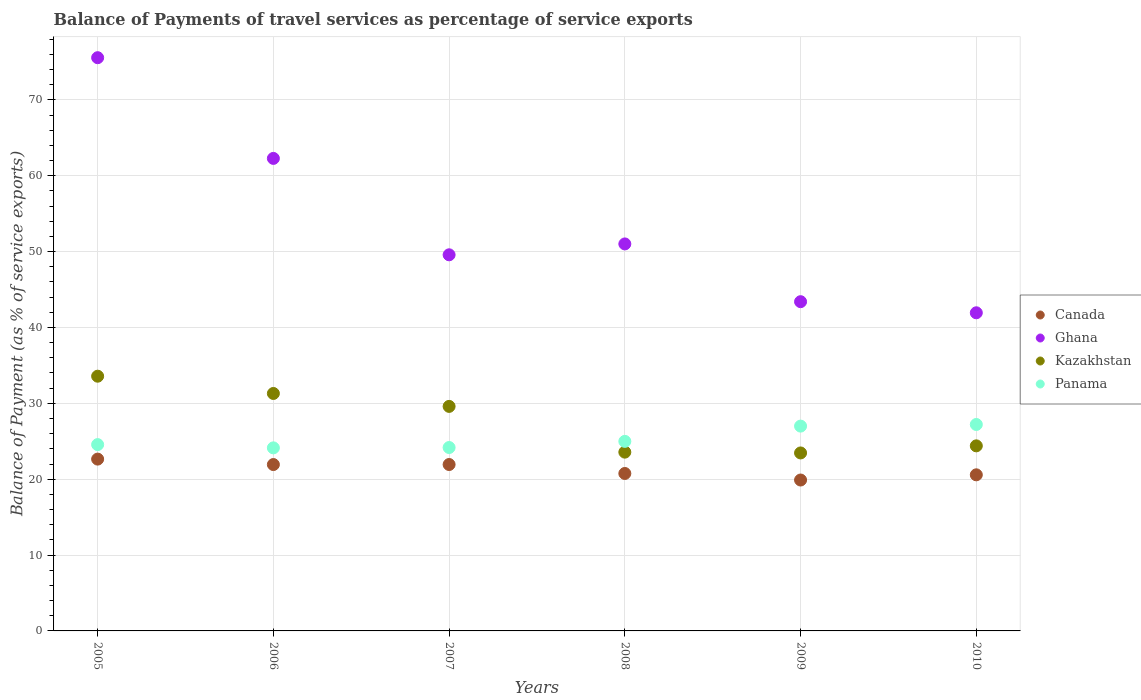How many different coloured dotlines are there?
Give a very brief answer. 4. Is the number of dotlines equal to the number of legend labels?
Provide a short and direct response. Yes. What is the balance of payments of travel services in Panama in 2007?
Your answer should be very brief. 24.18. Across all years, what is the maximum balance of payments of travel services in Kazakhstan?
Keep it short and to the point. 33.58. Across all years, what is the minimum balance of payments of travel services in Panama?
Your answer should be compact. 24.13. What is the total balance of payments of travel services in Ghana in the graph?
Provide a short and direct response. 323.78. What is the difference between the balance of payments of travel services in Panama in 2005 and that in 2010?
Your response must be concise. -2.65. What is the difference between the balance of payments of travel services in Kazakhstan in 2006 and the balance of payments of travel services in Canada in 2010?
Your answer should be compact. 10.72. What is the average balance of payments of travel services in Panama per year?
Offer a very short reply. 25.34. In the year 2010, what is the difference between the balance of payments of travel services in Canada and balance of payments of travel services in Ghana?
Offer a terse response. -21.36. In how many years, is the balance of payments of travel services in Kazakhstan greater than 64 %?
Ensure brevity in your answer.  0. What is the ratio of the balance of payments of travel services in Panama in 2005 to that in 2010?
Ensure brevity in your answer.  0.9. Is the balance of payments of travel services in Panama in 2009 less than that in 2010?
Make the answer very short. Yes. Is the difference between the balance of payments of travel services in Canada in 2007 and 2008 greater than the difference between the balance of payments of travel services in Ghana in 2007 and 2008?
Offer a terse response. Yes. What is the difference between the highest and the second highest balance of payments of travel services in Canada?
Keep it short and to the point. 0.71. What is the difference between the highest and the lowest balance of payments of travel services in Ghana?
Your answer should be very brief. 33.63. Is it the case that in every year, the sum of the balance of payments of travel services in Canada and balance of payments of travel services in Ghana  is greater than the sum of balance of payments of travel services in Panama and balance of payments of travel services in Kazakhstan?
Offer a very short reply. No. Is it the case that in every year, the sum of the balance of payments of travel services in Ghana and balance of payments of travel services in Canada  is greater than the balance of payments of travel services in Panama?
Provide a succinct answer. Yes. Does the balance of payments of travel services in Panama monotonically increase over the years?
Provide a succinct answer. No. Is the balance of payments of travel services in Canada strictly less than the balance of payments of travel services in Kazakhstan over the years?
Provide a succinct answer. Yes. How many dotlines are there?
Your response must be concise. 4. How many years are there in the graph?
Your answer should be compact. 6. Are the values on the major ticks of Y-axis written in scientific E-notation?
Your answer should be compact. No. Does the graph contain any zero values?
Your response must be concise. No. Does the graph contain grids?
Offer a very short reply. Yes. Where does the legend appear in the graph?
Offer a terse response. Center right. How many legend labels are there?
Make the answer very short. 4. What is the title of the graph?
Your response must be concise. Balance of Payments of travel services as percentage of service exports. What is the label or title of the X-axis?
Your response must be concise. Years. What is the label or title of the Y-axis?
Offer a very short reply. Balance of Payment (as % of service exports). What is the Balance of Payment (as % of service exports) of Canada in 2005?
Your response must be concise. 22.65. What is the Balance of Payment (as % of service exports) of Ghana in 2005?
Your answer should be compact. 75.56. What is the Balance of Payment (as % of service exports) in Kazakhstan in 2005?
Make the answer very short. 33.58. What is the Balance of Payment (as % of service exports) in Panama in 2005?
Give a very brief answer. 24.56. What is the Balance of Payment (as % of service exports) of Canada in 2006?
Your response must be concise. 21.93. What is the Balance of Payment (as % of service exports) of Ghana in 2006?
Make the answer very short. 62.29. What is the Balance of Payment (as % of service exports) in Kazakhstan in 2006?
Your answer should be compact. 31.3. What is the Balance of Payment (as % of service exports) of Panama in 2006?
Your response must be concise. 24.13. What is the Balance of Payment (as % of service exports) in Canada in 2007?
Your response must be concise. 21.94. What is the Balance of Payment (as % of service exports) of Ghana in 2007?
Provide a succinct answer. 49.58. What is the Balance of Payment (as % of service exports) of Kazakhstan in 2007?
Ensure brevity in your answer.  29.6. What is the Balance of Payment (as % of service exports) in Panama in 2007?
Your response must be concise. 24.18. What is the Balance of Payment (as % of service exports) in Canada in 2008?
Your answer should be compact. 20.75. What is the Balance of Payment (as % of service exports) in Ghana in 2008?
Your answer should be very brief. 51.01. What is the Balance of Payment (as % of service exports) in Kazakhstan in 2008?
Keep it short and to the point. 23.57. What is the Balance of Payment (as % of service exports) in Panama in 2008?
Offer a terse response. 24.99. What is the Balance of Payment (as % of service exports) in Canada in 2009?
Provide a succinct answer. 19.89. What is the Balance of Payment (as % of service exports) of Ghana in 2009?
Provide a short and direct response. 43.4. What is the Balance of Payment (as % of service exports) in Kazakhstan in 2009?
Offer a very short reply. 23.46. What is the Balance of Payment (as % of service exports) of Panama in 2009?
Offer a terse response. 27. What is the Balance of Payment (as % of service exports) of Canada in 2010?
Your answer should be very brief. 20.58. What is the Balance of Payment (as % of service exports) in Ghana in 2010?
Make the answer very short. 41.94. What is the Balance of Payment (as % of service exports) in Kazakhstan in 2010?
Give a very brief answer. 24.39. What is the Balance of Payment (as % of service exports) of Panama in 2010?
Your answer should be compact. 27.21. Across all years, what is the maximum Balance of Payment (as % of service exports) in Canada?
Provide a succinct answer. 22.65. Across all years, what is the maximum Balance of Payment (as % of service exports) in Ghana?
Make the answer very short. 75.56. Across all years, what is the maximum Balance of Payment (as % of service exports) in Kazakhstan?
Give a very brief answer. 33.58. Across all years, what is the maximum Balance of Payment (as % of service exports) of Panama?
Your response must be concise. 27.21. Across all years, what is the minimum Balance of Payment (as % of service exports) of Canada?
Offer a terse response. 19.89. Across all years, what is the minimum Balance of Payment (as % of service exports) in Ghana?
Provide a short and direct response. 41.94. Across all years, what is the minimum Balance of Payment (as % of service exports) in Kazakhstan?
Your response must be concise. 23.46. Across all years, what is the minimum Balance of Payment (as % of service exports) in Panama?
Offer a terse response. 24.13. What is the total Balance of Payment (as % of service exports) in Canada in the graph?
Offer a terse response. 127.74. What is the total Balance of Payment (as % of service exports) of Ghana in the graph?
Give a very brief answer. 323.78. What is the total Balance of Payment (as % of service exports) in Kazakhstan in the graph?
Your answer should be compact. 165.9. What is the total Balance of Payment (as % of service exports) in Panama in the graph?
Offer a terse response. 152.06. What is the difference between the Balance of Payment (as % of service exports) of Canada in 2005 and that in 2006?
Ensure brevity in your answer.  0.72. What is the difference between the Balance of Payment (as % of service exports) of Ghana in 2005 and that in 2006?
Your answer should be compact. 13.28. What is the difference between the Balance of Payment (as % of service exports) of Kazakhstan in 2005 and that in 2006?
Give a very brief answer. 2.28. What is the difference between the Balance of Payment (as % of service exports) in Panama in 2005 and that in 2006?
Your response must be concise. 0.43. What is the difference between the Balance of Payment (as % of service exports) in Canada in 2005 and that in 2007?
Offer a terse response. 0.71. What is the difference between the Balance of Payment (as % of service exports) of Ghana in 2005 and that in 2007?
Your answer should be compact. 25.98. What is the difference between the Balance of Payment (as % of service exports) of Kazakhstan in 2005 and that in 2007?
Your response must be concise. 3.98. What is the difference between the Balance of Payment (as % of service exports) in Panama in 2005 and that in 2007?
Make the answer very short. 0.38. What is the difference between the Balance of Payment (as % of service exports) in Canada in 2005 and that in 2008?
Provide a short and direct response. 1.9. What is the difference between the Balance of Payment (as % of service exports) of Ghana in 2005 and that in 2008?
Provide a short and direct response. 24.55. What is the difference between the Balance of Payment (as % of service exports) of Kazakhstan in 2005 and that in 2008?
Give a very brief answer. 10.01. What is the difference between the Balance of Payment (as % of service exports) of Panama in 2005 and that in 2008?
Make the answer very short. -0.43. What is the difference between the Balance of Payment (as % of service exports) in Canada in 2005 and that in 2009?
Provide a short and direct response. 2.76. What is the difference between the Balance of Payment (as % of service exports) of Ghana in 2005 and that in 2009?
Offer a terse response. 32.16. What is the difference between the Balance of Payment (as % of service exports) of Kazakhstan in 2005 and that in 2009?
Provide a short and direct response. 10.12. What is the difference between the Balance of Payment (as % of service exports) of Panama in 2005 and that in 2009?
Your answer should be compact. -2.44. What is the difference between the Balance of Payment (as % of service exports) in Canada in 2005 and that in 2010?
Offer a very short reply. 2.07. What is the difference between the Balance of Payment (as % of service exports) in Ghana in 2005 and that in 2010?
Your answer should be very brief. 33.63. What is the difference between the Balance of Payment (as % of service exports) in Kazakhstan in 2005 and that in 2010?
Offer a terse response. 9.18. What is the difference between the Balance of Payment (as % of service exports) in Panama in 2005 and that in 2010?
Your answer should be compact. -2.65. What is the difference between the Balance of Payment (as % of service exports) of Canada in 2006 and that in 2007?
Your answer should be very brief. -0.01. What is the difference between the Balance of Payment (as % of service exports) in Ghana in 2006 and that in 2007?
Keep it short and to the point. 12.71. What is the difference between the Balance of Payment (as % of service exports) of Kazakhstan in 2006 and that in 2007?
Ensure brevity in your answer.  1.7. What is the difference between the Balance of Payment (as % of service exports) in Panama in 2006 and that in 2007?
Keep it short and to the point. -0.04. What is the difference between the Balance of Payment (as % of service exports) of Canada in 2006 and that in 2008?
Provide a succinct answer. 1.18. What is the difference between the Balance of Payment (as % of service exports) of Ghana in 2006 and that in 2008?
Provide a succinct answer. 11.27. What is the difference between the Balance of Payment (as % of service exports) of Kazakhstan in 2006 and that in 2008?
Keep it short and to the point. 7.73. What is the difference between the Balance of Payment (as % of service exports) in Panama in 2006 and that in 2008?
Ensure brevity in your answer.  -0.86. What is the difference between the Balance of Payment (as % of service exports) of Canada in 2006 and that in 2009?
Give a very brief answer. 2.04. What is the difference between the Balance of Payment (as % of service exports) of Ghana in 2006 and that in 2009?
Ensure brevity in your answer.  18.89. What is the difference between the Balance of Payment (as % of service exports) of Kazakhstan in 2006 and that in 2009?
Your response must be concise. 7.84. What is the difference between the Balance of Payment (as % of service exports) of Panama in 2006 and that in 2009?
Your answer should be very brief. -2.87. What is the difference between the Balance of Payment (as % of service exports) in Canada in 2006 and that in 2010?
Your response must be concise. 1.35. What is the difference between the Balance of Payment (as % of service exports) of Ghana in 2006 and that in 2010?
Offer a very short reply. 20.35. What is the difference between the Balance of Payment (as % of service exports) of Kazakhstan in 2006 and that in 2010?
Keep it short and to the point. 6.91. What is the difference between the Balance of Payment (as % of service exports) of Panama in 2006 and that in 2010?
Your answer should be compact. -3.08. What is the difference between the Balance of Payment (as % of service exports) of Canada in 2007 and that in 2008?
Ensure brevity in your answer.  1.18. What is the difference between the Balance of Payment (as % of service exports) of Ghana in 2007 and that in 2008?
Offer a terse response. -1.43. What is the difference between the Balance of Payment (as % of service exports) in Kazakhstan in 2007 and that in 2008?
Give a very brief answer. 6.03. What is the difference between the Balance of Payment (as % of service exports) of Panama in 2007 and that in 2008?
Your answer should be very brief. -0.81. What is the difference between the Balance of Payment (as % of service exports) in Canada in 2007 and that in 2009?
Your answer should be very brief. 2.04. What is the difference between the Balance of Payment (as % of service exports) of Ghana in 2007 and that in 2009?
Ensure brevity in your answer.  6.18. What is the difference between the Balance of Payment (as % of service exports) of Kazakhstan in 2007 and that in 2009?
Provide a short and direct response. 6.14. What is the difference between the Balance of Payment (as % of service exports) in Panama in 2007 and that in 2009?
Provide a succinct answer. -2.82. What is the difference between the Balance of Payment (as % of service exports) of Canada in 2007 and that in 2010?
Your answer should be very brief. 1.36. What is the difference between the Balance of Payment (as % of service exports) of Ghana in 2007 and that in 2010?
Offer a terse response. 7.64. What is the difference between the Balance of Payment (as % of service exports) in Kazakhstan in 2007 and that in 2010?
Offer a very short reply. 5.2. What is the difference between the Balance of Payment (as % of service exports) of Panama in 2007 and that in 2010?
Offer a terse response. -3.04. What is the difference between the Balance of Payment (as % of service exports) in Canada in 2008 and that in 2009?
Your answer should be compact. 0.86. What is the difference between the Balance of Payment (as % of service exports) in Ghana in 2008 and that in 2009?
Keep it short and to the point. 7.61. What is the difference between the Balance of Payment (as % of service exports) in Kazakhstan in 2008 and that in 2009?
Offer a very short reply. 0.11. What is the difference between the Balance of Payment (as % of service exports) of Panama in 2008 and that in 2009?
Provide a succinct answer. -2.01. What is the difference between the Balance of Payment (as % of service exports) of Canada in 2008 and that in 2010?
Offer a very short reply. 0.18. What is the difference between the Balance of Payment (as % of service exports) of Ghana in 2008 and that in 2010?
Offer a terse response. 9.08. What is the difference between the Balance of Payment (as % of service exports) in Kazakhstan in 2008 and that in 2010?
Keep it short and to the point. -0.83. What is the difference between the Balance of Payment (as % of service exports) in Panama in 2008 and that in 2010?
Ensure brevity in your answer.  -2.22. What is the difference between the Balance of Payment (as % of service exports) of Canada in 2009 and that in 2010?
Give a very brief answer. -0.69. What is the difference between the Balance of Payment (as % of service exports) of Ghana in 2009 and that in 2010?
Your answer should be compact. 1.46. What is the difference between the Balance of Payment (as % of service exports) of Kazakhstan in 2009 and that in 2010?
Keep it short and to the point. -0.93. What is the difference between the Balance of Payment (as % of service exports) of Panama in 2009 and that in 2010?
Your answer should be compact. -0.21. What is the difference between the Balance of Payment (as % of service exports) in Canada in 2005 and the Balance of Payment (as % of service exports) in Ghana in 2006?
Your answer should be very brief. -39.64. What is the difference between the Balance of Payment (as % of service exports) of Canada in 2005 and the Balance of Payment (as % of service exports) of Kazakhstan in 2006?
Ensure brevity in your answer.  -8.65. What is the difference between the Balance of Payment (as % of service exports) in Canada in 2005 and the Balance of Payment (as % of service exports) in Panama in 2006?
Provide a short and direct response. -1.48. What is the difference between the Balance of Payment (as % of service exports) of Ghana in 2005 and the Balance of Payment (as % of service exports) of Kazakhstan in 2006?
Keep it short and to the point. 44.26. What is the difference between the Balance of Payment (as % of service exports) in Ghana in 2005 and the Balance of Payment (as % of service exports) in Panama in 2006?
Make the answer very short. 51.43. What is the difference between the Balance of Payment (as % of service exports) in Kazakhstan in 2005 and the Balance of Payment (as % of service exports) in Panama in 2006?
Ensure brevity in your answer.  9.45. What is the difference between the Balance of Payment (as % of service exports) in Canada in 2005 and the Balance of Payment (as % of service exports) in Ghana in 2007?
Ensure brevity in your answer.  -26.93. What is the difference between the Balance of Payment (as % of service exports) of Canada in 2005 and the Balance of Payment (as % of service exports) of Kazakhstan in 2007?
Offer a very short reply. -6.95. What is the difference between the Balance of Payment (as % of service exports) in Canada in 2005 and the Balance of Payment (as % of service exports) in Panama in 2007?
Keep it short and to the point. -1.53. What is the difference between the Balance of Payment (as % of service exports) of Ghana in 2005 and the Balance of Payment (as % of service exports) of Kazakhstan in 2007?
Your response must be concise. 45.97. What is the difference between the Balance of Payment (as % of service exports) in Ghana in 2005 and the Balance of Payment (as % of service exports) in Panama in 2007?
Offer a terse response. 51.39. What is the difference between the Balance of Payment (as % of service exports) of Kazakhstan in 2005 and the Balance of Payment (as % of service exports) of Panama in 2007?
Ensure brevity in your answer.  9.4. What is the difference between the Balance of Payment (as % of service exports) in Canada in 2005 and the Balance of Payment (as % of service exports) in Ghana in 2008?
Provide a short and direct response. -28.36. What is the difference between the Balance of Payment (as % of service exports) in Canada in 2005 and the Balance of Payment (as % of service exports) in Kazakhstan in 2008?
Provide a short and direct response. -0.92. What is the difference between the Balance of Payment (as % of service exports) of Canada in 2005 and the Balance of Payment (as % of service exports) of Panama in 2008?
Give a very brief answer. -2.34. What is the difference between the Balance of Payment (as % of service exports) of Ghana in 2005 and the Balance of Payment (as % of service exports) of Kazakhstan in 2008?
Your answer should be compact. 52. What is the difference between the Balance of Payment (as % of service exports) in Ghana in 2005 and the Balance of Payment (as % of service exports) in Panama in 2008?
Make the answer very short. 50.58. What is the difference between the Balance of Payment (as % of service exports) in Kazakhstan in 2005 and the Balance of Payment (as % of service exports) in Panama in 2008?
Your response must be concise. 8.59. What is the difference between the Balance of Payment (as % of service exports) in Canada in 2005 and the Balance of Payment (as % of service exports) in Ghana in 2009?
Provide a short and direct response. -20.75. What is the difference between the Balance of Payment (as % of service exports) in Canada in 2005 and the Balance of Payment (as % of service exports) in Kazakhstan in 2009?
Your answer should be compact. -0.81. What is the difference between the Balance of Payment (as % of service exports) in Canada in 2005 and the Balance of Payment (as % of service exports) in Panama in 2009?
Give a very brief answer. -4.35. What is the difference between the Balance of Payment (as % of service exports) in Ghana in 2005 and the Balance of Payment (as % of service exports) in Kazakhstan in 2009?
Keep it short and to the point. 52.1. What is the difference between the Balance of Payment (as % of service exports) of Ghana in 2005 and the Balance of Payment (as % of service exports) of Panama in 2009?
Offer a terse response. 48.56. What is the difference between the Balance of Payment (as % of service exports) of Kazakhstan in 2005 and the Balance of Payment (as % of service exports) of Panama in 2009?
Your answer should be compact. 6.58. What is the difference between the Balance of Payment (as % of service exports) of Canada in 2005 and the Balance of Payment (as % of service exports) of Ghana in 2010?
Keep it short and to the point. -19.29. What is the difference between the Balance of Payment (as % of service exports) of Canada in 2005 and the Balance of Payment (as % of service exports) of Kazakhstan in 2010?
Ensure brevity in your answer.  -1.75. What is the difference between the Balance of Payment (as % of service exports) in Canada in 2005 and the Balance of Payment (as % of service exports) in Panama in 2010?
Make the answer very short. -4.56. What is the difference between the Balance of Payment (as % of service exports) in Ghana in 2005 and the Balance of Payment (as % of service exports) in Kazakhstan in 2010?
Provide a succinct answer. 51.17. What is the difference between the Balance of Payment (as % of service exports) of Ghana in 2005 and the Balance of Payment (as % of service exports) of Panama in 2010?
Your answer should be compact. 48.35. What is the difference between the Balance of Payment (as % of service exports) of Kazakhstan in 2005 and the Balance of Payment (as % of service exports) of Panama in 2010?
Your response must be concise. 6.37. What is the difference between the Balance of Payment (as % of service exports) in Canada in 2006 and the Balance of Payment (as % of service exports) in Ghana in 2007?
Offer a very short reply. -27.65. What is the difference between the Balance of Payment (as % of service exports) of Canada in 2006 and the Balance of Payment (as % of service exports) of Kazakhstan in 2007?
Make the answer very short. -7.67. What is the difference between the Balance of Payment (as % of service exports) of Canada in 2006 and the Balance of Payment (as % of service exports) of Panama in 2007?
Provide a succinct answer. -2.25. What is the difference between the Balance of Payment (as % of service exports) of Ghana in 2006 and the Balance of Payment (as % of service exports) of Kazakhstan in 2007?
Provide a short and direct response. 32.69. What is the difference between the Balance of Payment (as % of service exports) in Ghana in 2006 and the Balance of Payment (as % of service exports) in Panama in 2007?
Ensure brevity in your answer.  38.11. What is the difference between the Balance of Payment (as % of service exports) of Kazakhstan in 2006 and the Balance of Payment (as % of service exports) of Panama in 2007?
Offer a terse response. 7.13. What is the difference between the Balance of Payment (as % of service exports) in Canada in 2006 and the Balance of Payment (as % of service exports) in Ghana in 2008?
Your response must be concise. -29.08. What is the difference between the Balance of Payment (as % of service exports) in Canada in 2006 and the Balance of Payment (as % of service exports) in Kazakhstan in 2008?
Provide a succinct answer. -1.64. What is the difference between the Balance of Payment (as % of service exports) in Canada in 2006 and the Balance of Payment (as % of service exports) in Panama in 2008?
Keep it short and to the point. -3.06. What is the difference between the Balance of Payment (as % of service exports) of Ghana in 2006 and the Balance of Payment (as % of service exports) of Kazakhstan in 2008?
Your response must be concise. 38.72. What is the difference between the Balance of Payment (as % of service exports) of Ghana in 2006 and the Balance of Payment (as % of service exports) of Panama in 2008?
Ensure brevity in your answer.  37.3. What is the difference between the Balance of Payment (as % of service exports) of Kazakhstan in 2006 and the Balance of Payment (as % of service exports) of Panama in 2008?
Give a very brief answer. 6.31. What is the difference between the Balance of Payment (as % of service exports) of Canada in 2006 and the Balance of Payment (as % of service exports) of Ghana in 2009?
Provide a succinct answer. -21.47. What is the difference between the Balance of Payment (as % of service exports) in Canada in 2006 and the Balance of Payment (as % of service exports) in Kazakhstan in 2009?
Provide a short and direct response. -1.53. What is the difference between the Balance of Payment (as % of service exports) in Canada in 2006 and the Balance of Payment (as % of service exports) in Panama in 2009?
Give a very brief answer. -5.07. What is the difference between the Balance of Payment (as % of service exports) of Ghana in 2006 and the Balance of Payment (as % of service exports) of Kazakhstan in 2009?
Your answer should be very brief. 38.83. What is the difference between the Balance of Payment (as % of service exports) of Ghana in 2006 and the Balance of Payment (as % of service exports) of Panama in 2009?
Ensure brevity in your answer.  35.29. What is the difference between the Balance of Payment (as % of service exports) in Kazakhstan in 2006 and the Balance of Payment (as % of service exports) in Panama in 2009?
Your answer should be very brief. 4.3. What is the difference between the Balance of Payment (as % of service exports) of Canada in 2006 and the Balance of Payment (as % of service exports) of Ghana in 2010?
Offer a very short reply. -20.01. What is the difference between the Balance of Payment (as % of service exports) of Canada in 2006 and the Balance of Payment (as % of service exports) of Kazakhstan in 2010?
Give a very brief answer. -2.46. What is the difference between the Balance of Payment (as % of service exports) in Canada in 2006 and the Balance of Payment (as % of service exports) in Panama in 2010?
Offer a very short reply. -5.28. What is the difference between the Balance of Payment (as % of service exports) of Ghana in 2006 and the Balance of Payment (as % of service exports) of Kazakhstan in 2010?
Provide a short and direct response. 37.89. What is the difference between the Balance of Payment (as % of service exports) in Ghana in 2006 and the Balance of Payment (as % of service exports) in Panama in 2010?
Your answer should be very brief. 35.08. What is the difference between the Balance of Payment (as % of service exports) in Kazakhstan in 2006 and the Balance of Payment (as % of service exports) in Panama in 2010?
Ensure brevity in your answer.  4.09. What is the difference between the Balance of Payment (as % of service exports) in Canada in 2007 and the Balance of Payment (as % of service exports) in Ghana in 2008?
Give a very brief answer. -29.08. What is the difference between the Balance of Payment (as % of service exports) in Canada in 2007 and the Balance of Payment (as % of service exports) in Kazakhstan in 2008?
Give a very brief answer. -1.63. What is the difference between the Balance of Payment (as % of service exports) in Canada in 2007 and the Balance of Payment (as % of service exports) in Panama in 2008?
Make the answer very short. -3.05. What is the difference between the Balance of Payment (as % of service exports) in Ghana in 2007 and the Balance of Payment (as % of service exports) in Kazakhstan in 2008?
Provide a short and direct response. 26.01. What is the difference between the Balance of Payment (as % of service exports) of Ghana in 2007 and the Balance of Payment (as % of service exports) of Panama in 2008?
Ensure brevity in your answer.  24.59. What is the difference between the Balance of Payment (as % of service exports) in Kazakhstan in 2007 and the Balance of Payment (as % of service exports) in Panama in 2008?
Make the answer very short. 4.61. What is the difference between the Balance of Payment (as % of service exports) in Canada in 2007 and the Balance of Payment (as % of service exports) in Ghana in 2009?
Ensure brevity in your answer.  -21.46. What is the difference between the Balance of Payment (as % of service exports) in Canada in 2007 and the Balance of Payment (as % of service exports) in Kazakhstan in 2009?
Offer a terse response. -1.53. What is the difference between the Balance of Payment (as % of service exports) in Canada in 2007 and the Balance of Payment (as % of service exports) in Panama in 2009?
Provide a succinct answer. -5.06. What is the difference between the Balance of Payment (as % of service exports) in Ghana in 2007 and the Balance of Payment (as % of service exports) in Kazakhstan in 2009?
Ensure brevity in your answer.  26.12. What is the difference between the Balance of Payment (as % of service exports) in Ghana in 2007 and the Balance of Payment (as % of service exports) in Panama in 2009?
Your answer should be very brief. 22.58. What is the difference between the Balance of Payment (as % of service exports) in Kazakhstan in 2007 and the Balance of Payment (as % of service exports) in Panama in 2009?
Make the answer very short. 2.6. What is the difference between the Balance of Payment (as % of service exports) of Canada in 2007 and the Balance of Payment (as % of service exports) of Ghana in 2010?
Provide a succinct answer. -20. What is the difference between the Balance of Payment (as % of service exports) of Canada in 2007 and the Balance of Payment (as % of service exports) of Kazakhstan in 2010?
Make the answer very short. -2.46. What is the difference between the Balance of Payment (as % of service exports) of Canada in 2007 and the Balance of Payment (as % of service exports) of Panama in 2010?
Provide a succinct answer. -5.28. What is the difference between the Balance of Payment (as % of service exports) of Ghana in 2007 and the Balance of Payment (as % of service exports) of Kazakhstan in 2010?
Make the answer very short. 25.18. What is the difference between the Balance of Payment (as % of service exports) in Ghana in 2007 and the Balance of Payment (as % of service exports) in Panama in 2010?
Give a very brief answer. 22.37. What is the difference between the Balance of Payment (as % of service exports) of Kazakhstan in 2007 and the Balance of Payment (as % of service exports) of Panama in 2010?
Your response must be concise. 2.39. What is the difference between the Balance of Payment (as % of service exports) of Canada in 2008 and the Balance of Payment (as % of service exports) of Ghana in 2009?
Offer a very short reply. -22.65. What is the difference between the Balance of Payment (as % of service exports) of Canada in 2008 and the Balance of Payment (as % of service exports) of Kazakhstan in 2009?
Your answer should be compact. -2.71. What is the difference between the Balance of Payment (as % of service exports) in Canada in 2008 and the Balance of Payment (as % of service exports) in Panama in 2009?
Make the answer very short. -6.24. What is the difference between the Balance of Payment (as % of service exports) of Ghana in 2008 and the Balance of Payment (as % of service exports) of Kazakhstan in 2009?
Your response must be concise. 27.55. What is the difference between the Balance of Payment (as % of service exports) in Ghana in 2008 and the Balance of Payment (as % of service exports) in Panama in 2009?
Your answer should be compact. 24.01. What is the difference between the Balance of Payment (as % of service exports) in Kazakhstan in 2008 and the Balance of Payment (as % of service exports) in Panama in 2009?
Your answer should be very brief. -3.43. What is the difference between the Balance of Payment (as % of service exports) in Canada in 2008 and the Balance of Payment (as % of service exports) in Ghana in 2010?
Your answer should be very brief. -21.18. What is the difference between the Balance of Payment (as % of service exports) in Canada in 2008 and the Balance of Payment (as % of service exports) in Kazakhstan in 2010?
Your answer should be very brief. -3.64. What is the difference between the Balance of Payment (as % of service exports) in Canada in 2008 and the Balance of Payment (as % of service exports) in Panama in 2010?
Keep it short and to the point. -6.46. What is the difference between the Balance of Payment (as % of service exports) of Ghana in 2008 and the Balance of Payment (as % of service exports) of Kazakhstan in 2010?
Give a very brief answer. 26.62. What is the difference between the Balance of Payment (as % of service exports) in Ghana in 2008 and the Balance of Payment (as % of service exports) in Panama in 2010?
Ensure brevity in your answer.  23.8. What is the difference between the Balance of Payment (as % of service exports) of Kazakhstan in 2008 and the Balance of Payment (as % of service exports) of Panama in 2010?
Give a very brief answer. -3.65. What is the difference between the Balance of Payment (as % of service exports) of Canada in 2009 and the Balance of Payment (as % of service exports) of Ghana in 2010?
Offer a very short reply. -22.04. What is the difference between the Balance of Payment (as % of service exports) in Canada in 2009 and the Balance of Payment (as % of service exports) in Kazakhstan in 2010?
Your answer should be very brief. -4.5. What is the difference between the Balance of Payment (as % of service exports) in Canada in 2009 and the Balance of Payment (as % of service exports) in Panama in 2010?
Your answer should be very brief. -7.32. What is the difference between the Balance of Payment (as % of service exports) in Ghana in 2009 and the Balance of Payment (as % of service exports) in Kazakhstan in 2010?
Your answer should be compact. 19. What is the difference between the Balance of Payment (as % of service exports) of Ghana in 2009 and the Balance of Payment (as % of service exports) of Panama in 2010?
Ensure brevity in your answer.  16.19. What is the difference between the Balance of Payment (as % of service exports) of Kazakhstan in 2009 and the Balance of Payment (as % of service exports) of Panama in 2010?
Provide a short and direct response. -3.75. What is the average Balance of Payment (as % of service exports) of Canada per year?
Provide a succinct answer. 21.29. What is the average Balance of Payment (as % of service exports) in Ghana per year?
Offer a terse response. 53.96. What is the average Balance of Payment (as % of service exports) of Kazakhstan per year?
Your response must be concise. 27.65. What is the average Balance of Payment (as % of service exports) in Panama per year?
Your answer should be compact. 25.34. In the year 2005, what is the difference between the Balance of Payment (as % of service exports) in Canada and Balance of Payment (as % of service exports) in Ghana?
Provide a succinct answer. -52.91. In the year 2005, what is the difference between the Balance of Payment (as % of service exports) of Canada and Balance of Payment (as % of service exports) of Kazakhstan?
Provide a succinct answer. -10.93. In the year 2005, what is the difference between the Balance of Payment (as % of service exports) of Canada and Balance of Payment (as % of service exports) of Panama?
Ensure brevity in your answer.  -1.91. In the year 2005, what is the difference between the Balance of Payment (as % of service exports) of Ghana and Balance of Payment (as % of service exports) of Kazakhstan?
Your response must be concise. 41.99. In the year 2005, what is the difference between the Balance of Payment (as % of service exports) of Ghana and Balance of Payment (as % of service exports) of Panama?
Keep it short and to the point. 51. In the year 2005, what is the difference between the Balance of Payment (as % of service exports) of Kazakhstan and Balance of Payment (as % of service exports) of Panama?
Your response must be concise. 9.02. In the year 2006, what is the difference between the Balance of Payment (as % of service exports) of Canada and Balance of Payment (as % of service exports) of Ghana?
Make the answer very short. -40.36. In the year 2006, what is the difference between the Balance of Payment (as % of service exports) in Canada and Balance of Payment (as % of service exports) in Kazakhstan?
Offer a terse response. -9.37. In the year 2006, what is the difference between the Balance of Payment (as % of service exports) of Canada and Balance of Payment (as % of service exports) of Panama?
Provide a short and direct response. -2.2. In the year 2006, what is the difference between the Balance of Payment (as % of service exports) of Ghana and Balance of Payment (as % of service exports) of Kazakhstan?
Offer a terse response. 30.99. In the year 2006, what is the difference between the Balance of Payment (as % of service exports) of Ghana and Balance of Payment (as % of service exports) of Panama?
Provide a short and direct response. 38.16. In the year 2006, what is the difference between the Balance of Payment (as % of service exports) of Kazakhstan and Balance of Payment (as % of service exports) of Panama?
Provide a short and direct response. 7.17. In the year 2007, what is the difference between the Balance of Payment (as % of service exports) of Canada and Balance of Payment (as % of service exports) of Ghana?
Provide a short and direct response. -27.64. In the year 2007, what is the difference between the Balance of Payment (as % of service exports) in Canada and Balance of Payment (as % of service exports) in Kazakhstan?
Ensure brevity in your answer.  -7.66. In the year 2007, what is the difference between the Balance of Payment (as % of service exports) of Canada and Balance of Payment (as % of service exports) of Panama?
Ensure brevity in your answer.  -2.24. In the year 2007, what is the difference between the Balance of Payment (as % of service exports) of Ghana and Balance of Payment (as % of service exports) of Kazakhstan?
Provide a succinct answer. 19.98. In the year 2007, what is the difference between the Balance of Payment (as % of service exports) in Ghana and Balance of Payment (as % of service exports) in Panama?
Your answer should be compact. 25.4. In the year 2007, what is the difference between the Balance of Payment (as % of service exports) of Kazakhstan and Balance of Payment (as % of service exports) of Panama?
Ensure brevity in your answer.  5.42. In the year 2008, what is the difference between the Balance of Payment (as % of service exports) of Canada and Balance of Payment (as % of service exports) of Ghana?
Provide a succinct answer. -30.26. In the year 2008, what is the difference between the Balance of Payment (as % of service exports) in Canada and Balance of Payment (as % of service exports) in Kazakhstan?
Your answer should be very brief. -2.81. In the year 2008, what is the difference between the Balance of Payment (as % of service exports) in Canada and Balance of Payment (as % of service exports) in Panama?
Ensure brevity in your answer.  -4.23. In the year 2008, what is the difference between the Balance of Payment (as % of service exports) of Ghana and Balance of Payment (as % of service exports) of Kazakhstan?
Ensure brevity in your answer.  27.45. In the year 2008, what is the difference between the Balance of Payment (as % of service exports) in Ghana and Balance of Payment (as % of service exports) in Panama?
Offer a very short reply. 26.03. In the year 2008, what is the difference between the Balance of Payment (as % of service exports) in Kazakhstan and Balance of Payment (as % of service exports) in Panama?
Your answer should be compact. -1.42. In the year 2009, what is the difference between the Balance of Payment (as % of service exports) in Canada and Balance of Payment (as % of service exports) in Ghana?
Make the answer very short. -23.51. In the year 2009, what is the difference between the Balance of Payment (as % of service exports) of Canada and Balance of Payment (as % of service exports) of Kazakhstan?
Provide a short and direct response. -3.57. In the year 2009, what is the difference between the Balance of Payment (as % of service exports) of Canada and Balance of Payment (as % of service exports) of Panama?
Provide a short and direct response. -7.11. In the year 2009, what is the difference between the Balance of Payment (as % of service exports) in Ghana and Balance of Payment (as % of service exports) in Kazakhstan?
Provide a short and direct response. 19.94. In the year 2009, what is the difference between the Balance of Payment (as % of service exports) in Ghana and Balance of Payment (as % of service exports) in Panama?
Ensure brevity in your answer.  16.4. In the year 2009, what is the difference between the Balance of Payment (as % of service exports) in Kazakhstan and Balance of Payment (as % of service exports) in Panama?
Keep it short and to the point. -3.54. In the year 2010, what is the difference between the Balance of Payment (as % of service exports) of Canada and Balance of Payment (as % of service exports) of Ghana?
Your response must be concise. -21.36. In the year 2010, what is the difference between the Balance of Payment (as % of service exports) in Canada and Balance of Payment (as % of service exports) in Kazakhstan?
Your answer should be compact. -3.82. In the year 2010, what is the difference between the Balance of Payment (as % of service exports) in Canada and Balance of Payment (as % of service exports) in Panama?
Provide a succinct answer. -6.63. In the year 2010, what is the difference between the Balance of Payment (as % of service exports) in Ghana and Balance of Payment (as % of service exports) in Kazakhstan?
Keep it short and to the point. 17.54. In the year 2010, what is the difference between the Balance of Payment (as % of service exports) in Ghana and Balance of Payment (as % of service exports) in Panama?
Ensure brevity in your answer.  14.72. In the year 2010, what is the difference between the Balance of Payment (as % of service exports) of Kazakhstan and Balance of Payment (as % of service exports) of Panama?
Provide a succinct answer. -2.82. What is the ratio of the Balance of Payment (as % of service exports) in Canada in 2005 to that in 2006?
Offer a very short reply. 1.03. What is the ratio of the Balance of Payment (as % of service exports) of Ghana in 2005 to that in 2006?
Make the answer very short. 1.21. What is the ratio of the Balance of Payment (as % of service exports) in Kazakhstan in 2005 to that in 2006?
Your answer should be very brief. 1.07. What is the ratio of the Balance of Payment (as % of service exports) in Panama in 2005 to that in 2006?
Ensure brevity in your answer.  1.02. What is the ratio of the Balance of Payment (as % of service exports) of Canada in 2005 to that in 2007?
Offer a terse response. 1.03. What is the ratio of the Balance of Payment (as % of service exports) of Ghana in 2005 to that in 2007?
Your answer should be very brief. 1.52. What is the ratio of the Balance of Payment (as % of service exports) in Kazakhstan in 2005 to that in 2007?
Ensure brevity in your answer.  1.13. What is the ratio of the Balance of Payment (as % of service exports) in Panama in 2005 to that in 2007?
Make the answer very short. 1.02. What is the ratio of the Balance of Payment (as % of service exports) in Canada in 2005 to that in 2008?
Make the answer very short. 1.09. What is the ratio of the Balance of Payment (as % of service exports) in Ghana in 2005 to that in 2008?
Offer a very short reply. 1.48. What is the ratio of the Balance of Payment (as % of service exports) of Kazakhstan in 2005 to that in 2008?
Ensure brevity in your answer.  1.42. What is the ratio of the Balance of Payment (as % of service exports) in Panama in 2005 to that in 2008?
Give a very brief answer. 0.98. What is the ratio of the Balance of Payment (as % of service exports) in Canada in 2005 to that in 2009?
Your answer should be very brief. 1.14. What is the ratio of the Balance of Payment (as % of service exports) of Ghana in 2005 to that in 2009?
Keep it short and to the point. 1.74. What is the ratio of the Balance of Payment (as % of service exports) of Kazakhstan in 2005 to that in 2009?
Your answer should be compact. 1.43. What is the ratio of the Balance of Payment (as % of service exports) of Panama in 2005 to that in 2009?
Provide a short and direct response. 0.91. What is the ratio of the Balance of Payment (as % of service exports) in Canada in 2005 to that in 2010?
Make the answer very short. 1.1. What is the ratio of the Balance of Payment (as % of service exports) in Ghana in 2005 to that in 2010?
Ensure brevity in your answer.  1.8. What is the ratio of the Balance of Payment (as % of service exports) of Kazakhstan in 2005 to that in 2010?
Offer a very short reply. 1.38. What is the ratio of the Balance of Payment (as % of service exports) in Panama in 2005 to that in 2010?
Keep it short and to the point. 0.9. What is the ratio of the Balance of Payment (as % of service exports) of Canada in 2006 to that in 2007?
Provide a succinct answer. 1. What is the ratio of the Balance of Payment (as % of service exports) of Ghana in 2006 to that in 2007?
Make the answer very short. 1.26. What is the ratio of the Balance of Payment (as % of service exports) of Kazakhstan in 2006 to that in 2007?
Provide a succinct answer. 1.06. What is the ratio of the Balance of Payment (as % of service exports) in Panama in 2006 to that in 2007?
Keep it short and to the point. 1. What is the ratio of the Balance of Payment (as % of service exports) of Canada in 2006 to that in 2008?
Offer a terse response. 1.06. What is the ratio of the Balance of Payment (as % of service exports) in Ghana in 2006 to that in 2008?
Your answer should be very brief. 1.22. What is the ratio of the Balance of Payment (as % of service exports) in Kazakhstan in 2006 to that in 2008?
Ensure brevity in your answer.  1.33. What is the ratio of the Balance of Payment (as % of service exports) of Panama in 2006 to that in 2008?
Keep it short and to the point. 0.97. What is the ratio of the Balance of Payment (as % of service exports) in Canada in 2006 to that in 2009?
Your response must be concise. 1.1. What is the ratio of the Balance of Payment (as % of service exports) of Ghana in 2006 to that in 2009?
Provide a short and direct response. 1.44. What is the ratio of the Balance of Payment (as % of service exports) of Kazakhstan in 2006 to that in 2009?
Give a very brief answer. 1.33. What is the ratio of the Balance of Payment (as % of service exports) in Panama in 2006 to that in 2009?
Offer a terse response. 0.89. What is the ratio of the Balance of Payment (as % of service exports) in Canada in 2006 to that in 2010?
Give a very brief answer. 1.07. What is the ratio of the Balance of Payment (as % of service exports) of Ghana in 2006 to that in 2010?
Offer a terse response. 1.49. What is the ratio of the Balance of Payment (as % of service exports) of Kazakhstan in 2006 to that in 2010?
Provide a succinct answer. 1.28. What is the ratio of the Balance of Payment (as % of service exports) of Panama in 2006 to that in 2010?
Your answer should be compact. 0.89. What is the ratio of the Balance of Payment (as % of service exports) of Canada in 2007 to that in 2008?
Provide a short and direct response. 1.06. What is the ratio of the Balance of Payment (as % of service exports) of Ghana in 2007 to that in 2008?
Provide a short and direct response. 0.97. What is the ratio of the Balance of Payment (as % of service exports) in Kazakhstan in 2007 to that in 2008?
Keep it short and to the point. 1.26. What is the ratio of the Balance of Payment (as % of service exports) of Panama in 2007 to that in 2008?
Keep it short and to the point. 0.97. What is the ratio of the Balance of Payment (as % of service exports) of Canada in 2007 to that in 2009?
Offer a terse response. 1.1. What is the ratio of the Balance of Payment (as % of service exports) of Ghana in 2007 to that in 2009?
Ensure brevity in your answer.  1.14. What is the ratio of the Balance of Payment (as % of service exports) of Kazakhstan in 2007 to that in 2009?
Ensure brevity in your answer.  1.26. What is the ratio of the Balance of Payment (as % of service exports) in Panama in 2007 to that in 2009?
Provide a short and direct response. 0.9. What is the ratio of the Balance of Payment (as % of service exports) in Canada in 2007 to that in 2010?
Make the answer very short. 1.07. What is the ratio of the Balance of Payment (as % of service exports) of Ghana in 2007 to that in 2010?
Ensure brevity in your answer.  1.18. What is the ratio of the Balance of Payment (as % of service exports) of Kazakhstan in 2007 to that in 2010?
Keep it short and to the point. 1.21. What is the ratio of the Balance of Payment (as % of service exports) of Panama in 2007 to that in 2010?
Ensure brevity in your answer.  0.89. What is the ratio of the Balance of Payment (as % of service exports) of Canada in 2008 to that in 2009?
Offer a very short reply. 1.04. What is the ratio of the Balance of Payment (as % of service exports) of Ghana in 2008 to that in 2009?
Offer a terse response. 1.18. What is the ratio of the Balance of Payment (as % of service exports) of Kazakhstan in 2008 to that in 2009?
Give a very brief answer. 1. What is the ratio of the Balance of Payment (as % of service exports) in Panama in 2008 to that in 2009?
Your response must be concise. 0.93. What is the ratio of the Balance of Payment (as % of service exports) in Canada in 2008 to that in 2010?
Provide a short and direct response. 1.01. What is the ratio of the Balance of Payment (as % of service exports) in Ghana in 2008 to that in 2010?
Your answer should be very brief. 1.22. What is the ratio of the Balance of Payment (as % of service exports) in Kazakhstan in 2008 to that in 2010?
Offer a very short reply. 0.97. What is the ratio of the Balance of Payment (as % of service exports) in Panama in 2008 to that in 2010?
Your response must be concise. 0.92. What is the ratio of the Balance of Payment (as % of service exports) in Canada in 2009 to that in 2010?
Ensure brevity in your answer.  0.97. What is the ratio of the Balance of Payment (as % of service exports) in Ghana in 2009 to that in 2010?
Ensure brevity in your answer.  1.03. What is the ratio of the Balance of Payment (as % of service exports) in Kazakhstan in 2009 to that in 2010?
Give a very brief answer. 0.96. What is the difference between the highest and the second highest Balance of Payment (as % of service exports) in Canada?
Give a very brief answer. 0.71. What is the difference between the highest and the second highest Balance of Payment (as % of service exports) of Ghana?
Your response must be concise. 13.28. What is the difference between the highest and the second highest Balance of Payment (as % of service exports) in Kazakhstan?
Offer a terse response. 2.28. What is the difference between the highest and the second highest Balance of Payment (as % of service exports) of Panama?
Offer a very short reply. 0.21. What is the difference between the highest and the lowest Balance of Payment (as % of service exports) of Canada?
Keep it short and to the point. 2.76. What is the difference between the highest and the lowest Balance of Payment (as % of service exports) in Ghana?
Give a very brief answer. 33.63. What is the difference between the highest and the lowest Balance of Payment (as % of service exports) of Kazakhstan?
Your response must be concise. 10.12. What is the difference between the highest and the lowest Balance of Payment (as % of service exports) in Panama?
Your answer should be compact. 3.08. 